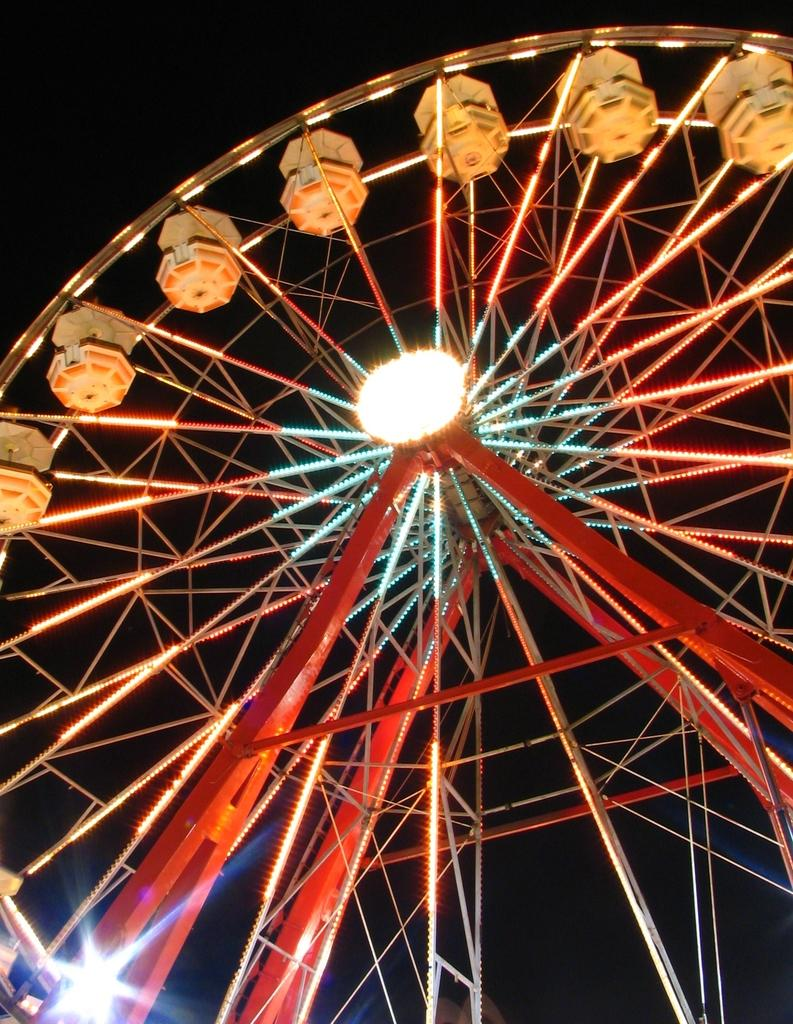What is the main subject of the image? There is an amusement ride in the image. How many sticks are used to create the word "fun" on the amusement ride? There is no mention of sticks or the word "fun" in the image, as it only features an amusement ride. 